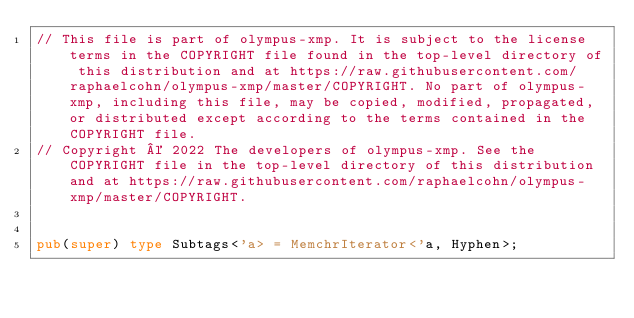Convert code to text. <code><loc_0><loc_0><loc_500><loc_500><_Rust_>// This file is part of olympus-xmp. It is subject to the license terms in the COPYRIGHT file found in the top-level directory of this distribution and at https://raw.githubusercontent.com/raphaelcohn/olympus-xmp/master/COPYRIGHT. No part of olympus-xmp, including this file, may be copied, modified, propagated, or distributed except according to the terms contained in the COPYRIGHT file.
// Copyright © 2022 The developers of olympus-xmp. See the COPYRIGHT file in the top-level directory of this distribution and at https://raw.githubusercontent.com/raphaelcohn/olympus-xmp/master/COPYRIGHT.


pub(super) type Subtags<'a> = MemchrIterator<'a, Hyphen>;
</code> 